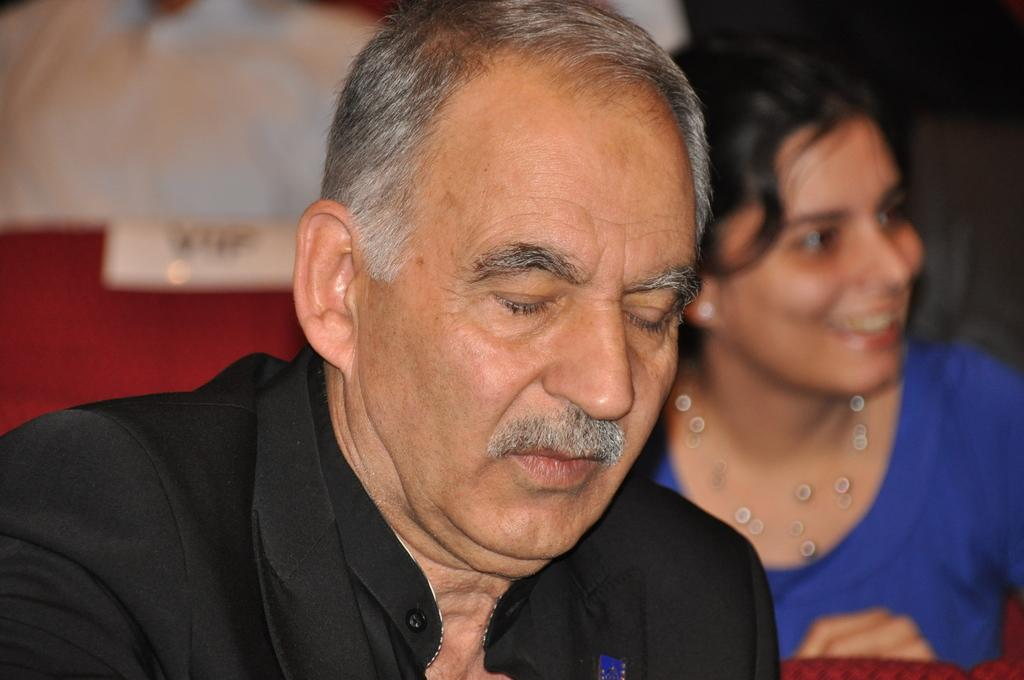How many people are in the image? There are two people in the image. Can you describe the background of the image? The background of the image is blurred. What type of winter clothing are the people wearing in the image? There is no mention of winter clothing or any specific season in the image, as the provided facts only mention the presence of two people and a blurred background. 